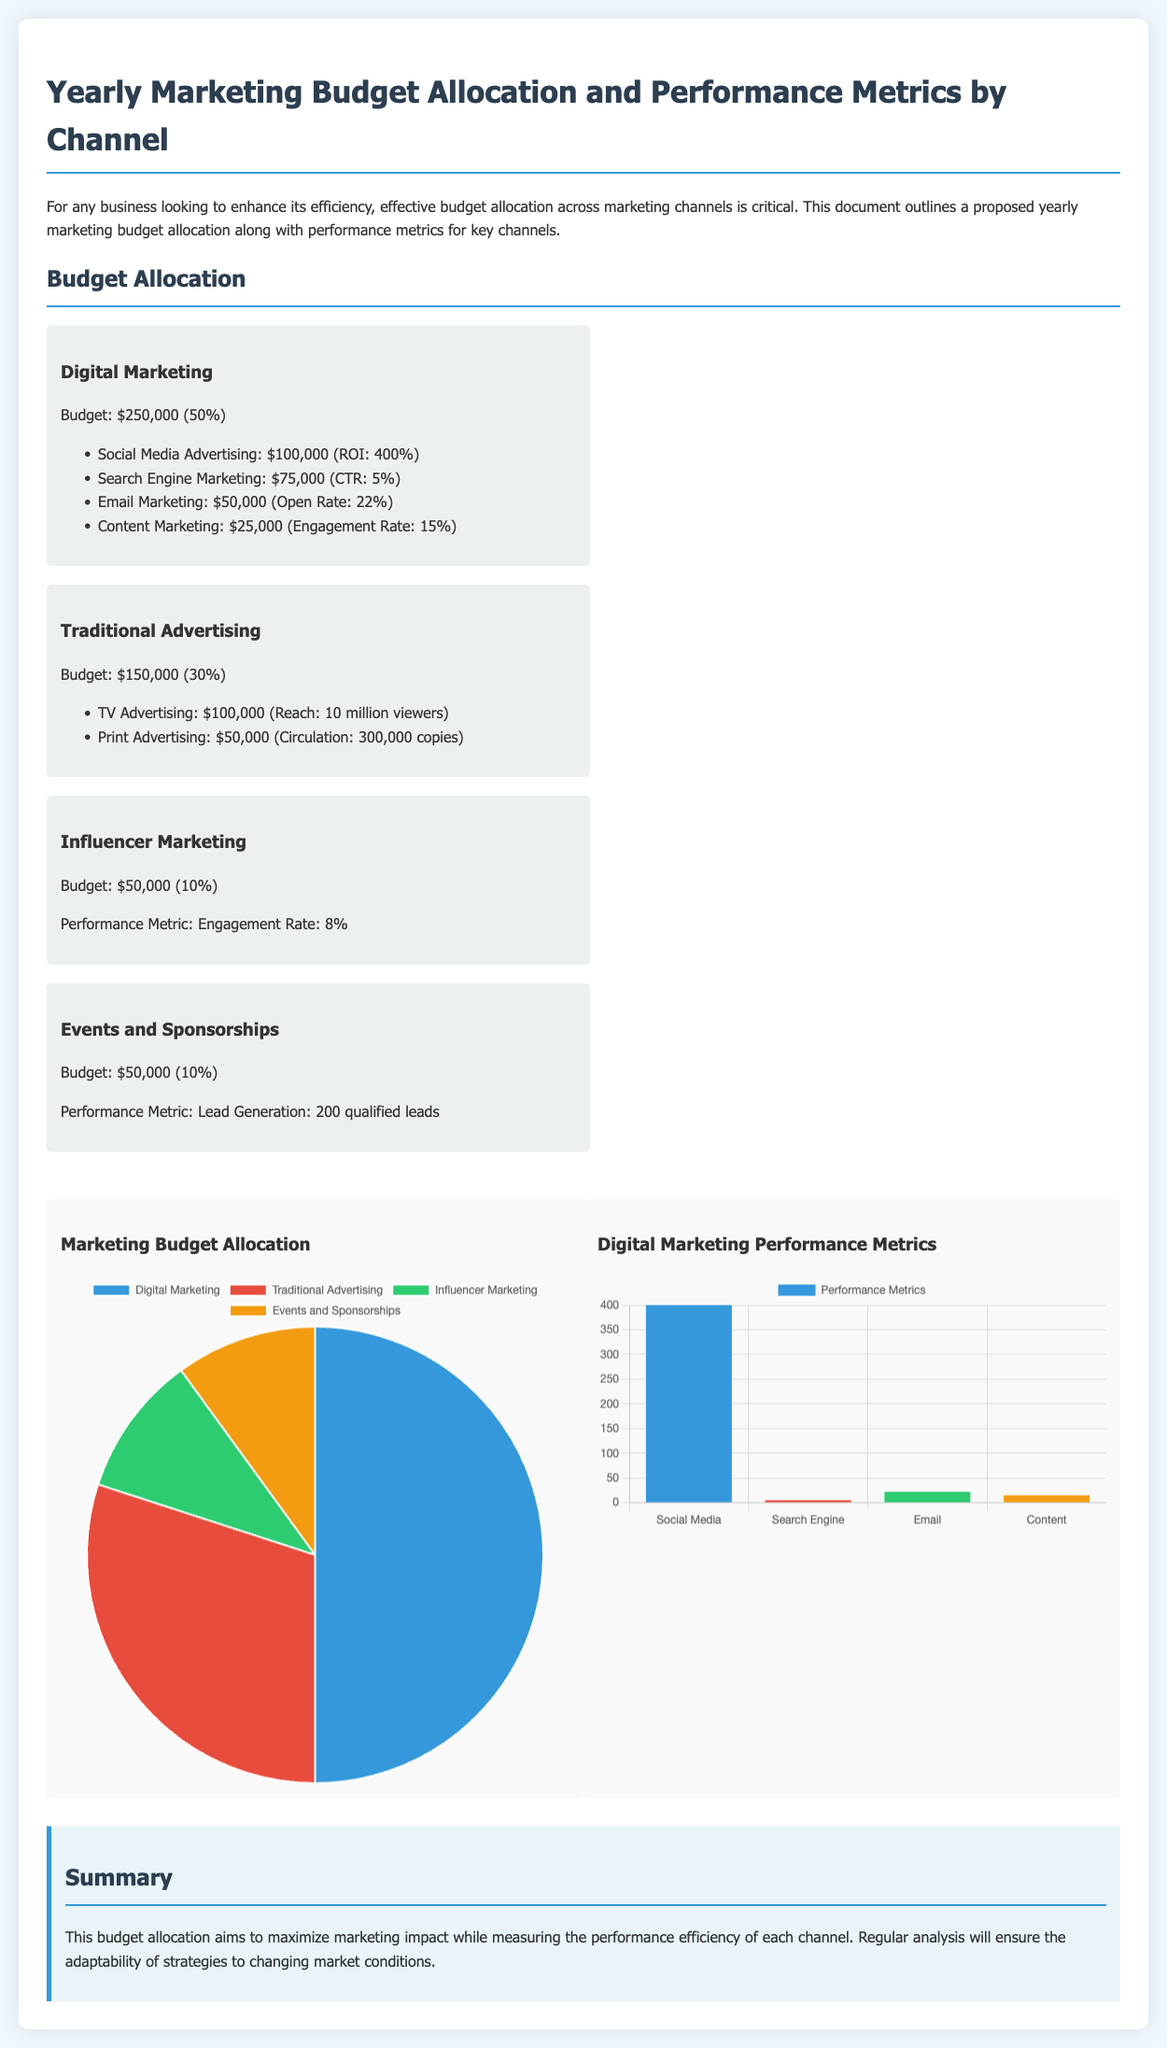What is the total budget for Digital Marketing? The total budget for Digital Marketing is explicitly stated as $250,000.
Answer: $250,000 What percentage of the budget is allocated to Traditional Advertising? The document indicates that Traditional Advertising accounts for 30% of the overall budget.
Answer: 30% How much is allocated to Social Media Advertising? The document specifies that Social Media Advertising has a budget of $100,000.
Answer: $100,000 What is the ROI for Social Media Advertising? The ROI for Social Media Advertising is listed as 400%.
Answer: 400% How many viewers does TV Advertising reach? The document states that TV Advertising reaches 10 million viewers.
Answer: 10 million viewers Which marketing channel has the lowest budget allocation? According to the budget allocation, Influencer Marketing has the lowest budget of $50,000.
Answer: Influencer Marketing What is the engagement rate for Content Marketing? The engagement rate for Content Marketing is mentioned as 15%.
Answer: 15% What performance metric is associated with Events and Sponsorships? The performance metric associated with Events and Sponsorships is Lead Generation: 200 qualified leads.
Answer: 200 qualified leads How many channels are included in the Digital Marketing category? The document lists four subcategories within Digital Marketing.
Answer: Four 